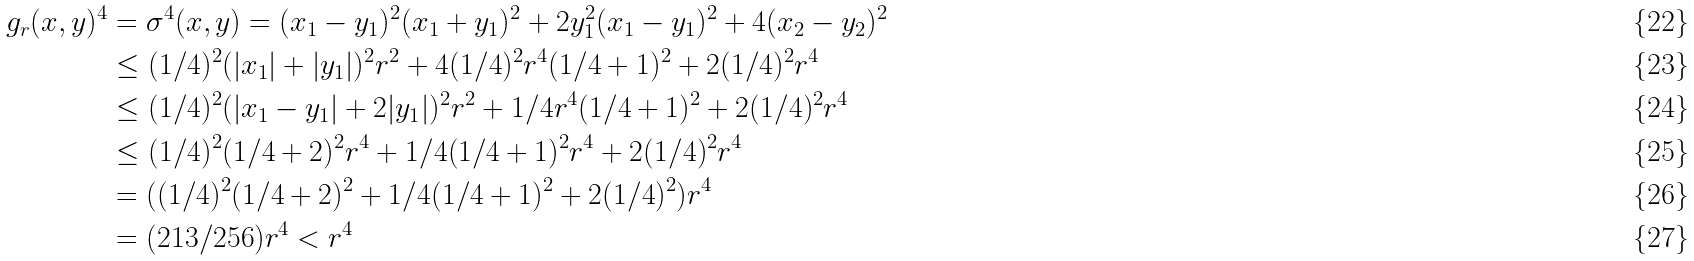<formula> <loc_0><loc_0><loc_500><loc_500>g _ { r } ( x , y ) ^ { 4 } & = \sigma ^ { 4 } ( x , y ) = ( x _ { 1 } - y _ { 1 } ) ^ { 2 } ( x _ { 1 } + y _ { 1 } ) ^ { 2 } + 2 y _ { 1 } ^ { 2 } ( x _ { 1 } - y _ { 1 } ) ^ { 2 } + 4 ( x _ { 2 } - y _ { 2 } ) ^ { 2 } \\ & \leq ( 1 / 4 ) ^ { 2 } ( | x _ { 1 } | + | y _ { 1 } | ) ^ { 2 } r ^ { 2 } + 4 ( 1 / 4 ) ^ { 2 } r ^ { 4 } ( 1 / 4 + 1 ) ^ { 2 } + 2 ( 1 / 4 ) ^ { 2 } r ^ { 4 } \\ & \leq ( 1 / 4 ) ^ { 2 } ( | x _ { 1 } - y _ { 1 } | + 2 | y _ { 1 } | ) ^ { 2 } r ^ { 2 } + 1 / 4 r ^ { 4 } ( 1 / 4 + 1 ) ^ { 2 } + 2 ( 1 / 4 ) ^ { 2 } r ^ { 4 } \\ & \leq ( 1 / 4 ) ^ { 2 } ( 1 / 4 + 2 ) ^ { 2 } r ^ { 4 } + 1 / 4 ( 1 / 4 + 1 ) ^ { 2 } r ^ { 4 } + 2 ( 1 / 4 ) ^ { 2 } r ^ { 4 } \\ & = ( ( 1 / 4 ) ^ { 2 } ( 1 / 4 + 2 ) ^ { 2 } + 1 / 4 ( 1 / 4 + 1 ) ^ { 2 } + 2 ( 1 / 4 ) ^ { 2 } ) r ^ { 4 } \\ & = ( 2 1 3 / 2 5 6 ) r ^ { 4 } < r ^ { 4 }</formula> 